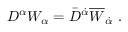Convert formula to latex. <formula><loc_0><loc_0><loc_500><loc_500>D ^ { \alpha } W _ { \alpha } = \bar { D } ^ { \dot { \alpha } } \overline { W } _ { \dot { \alpha } } .</formula> 